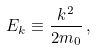<formula> <loc_0><loc_0><loc_500><loc_500>E _ { k } \equiv \frac { k ^ { 2 } } { 2 m _ { 0 } } \, ,</formula> 